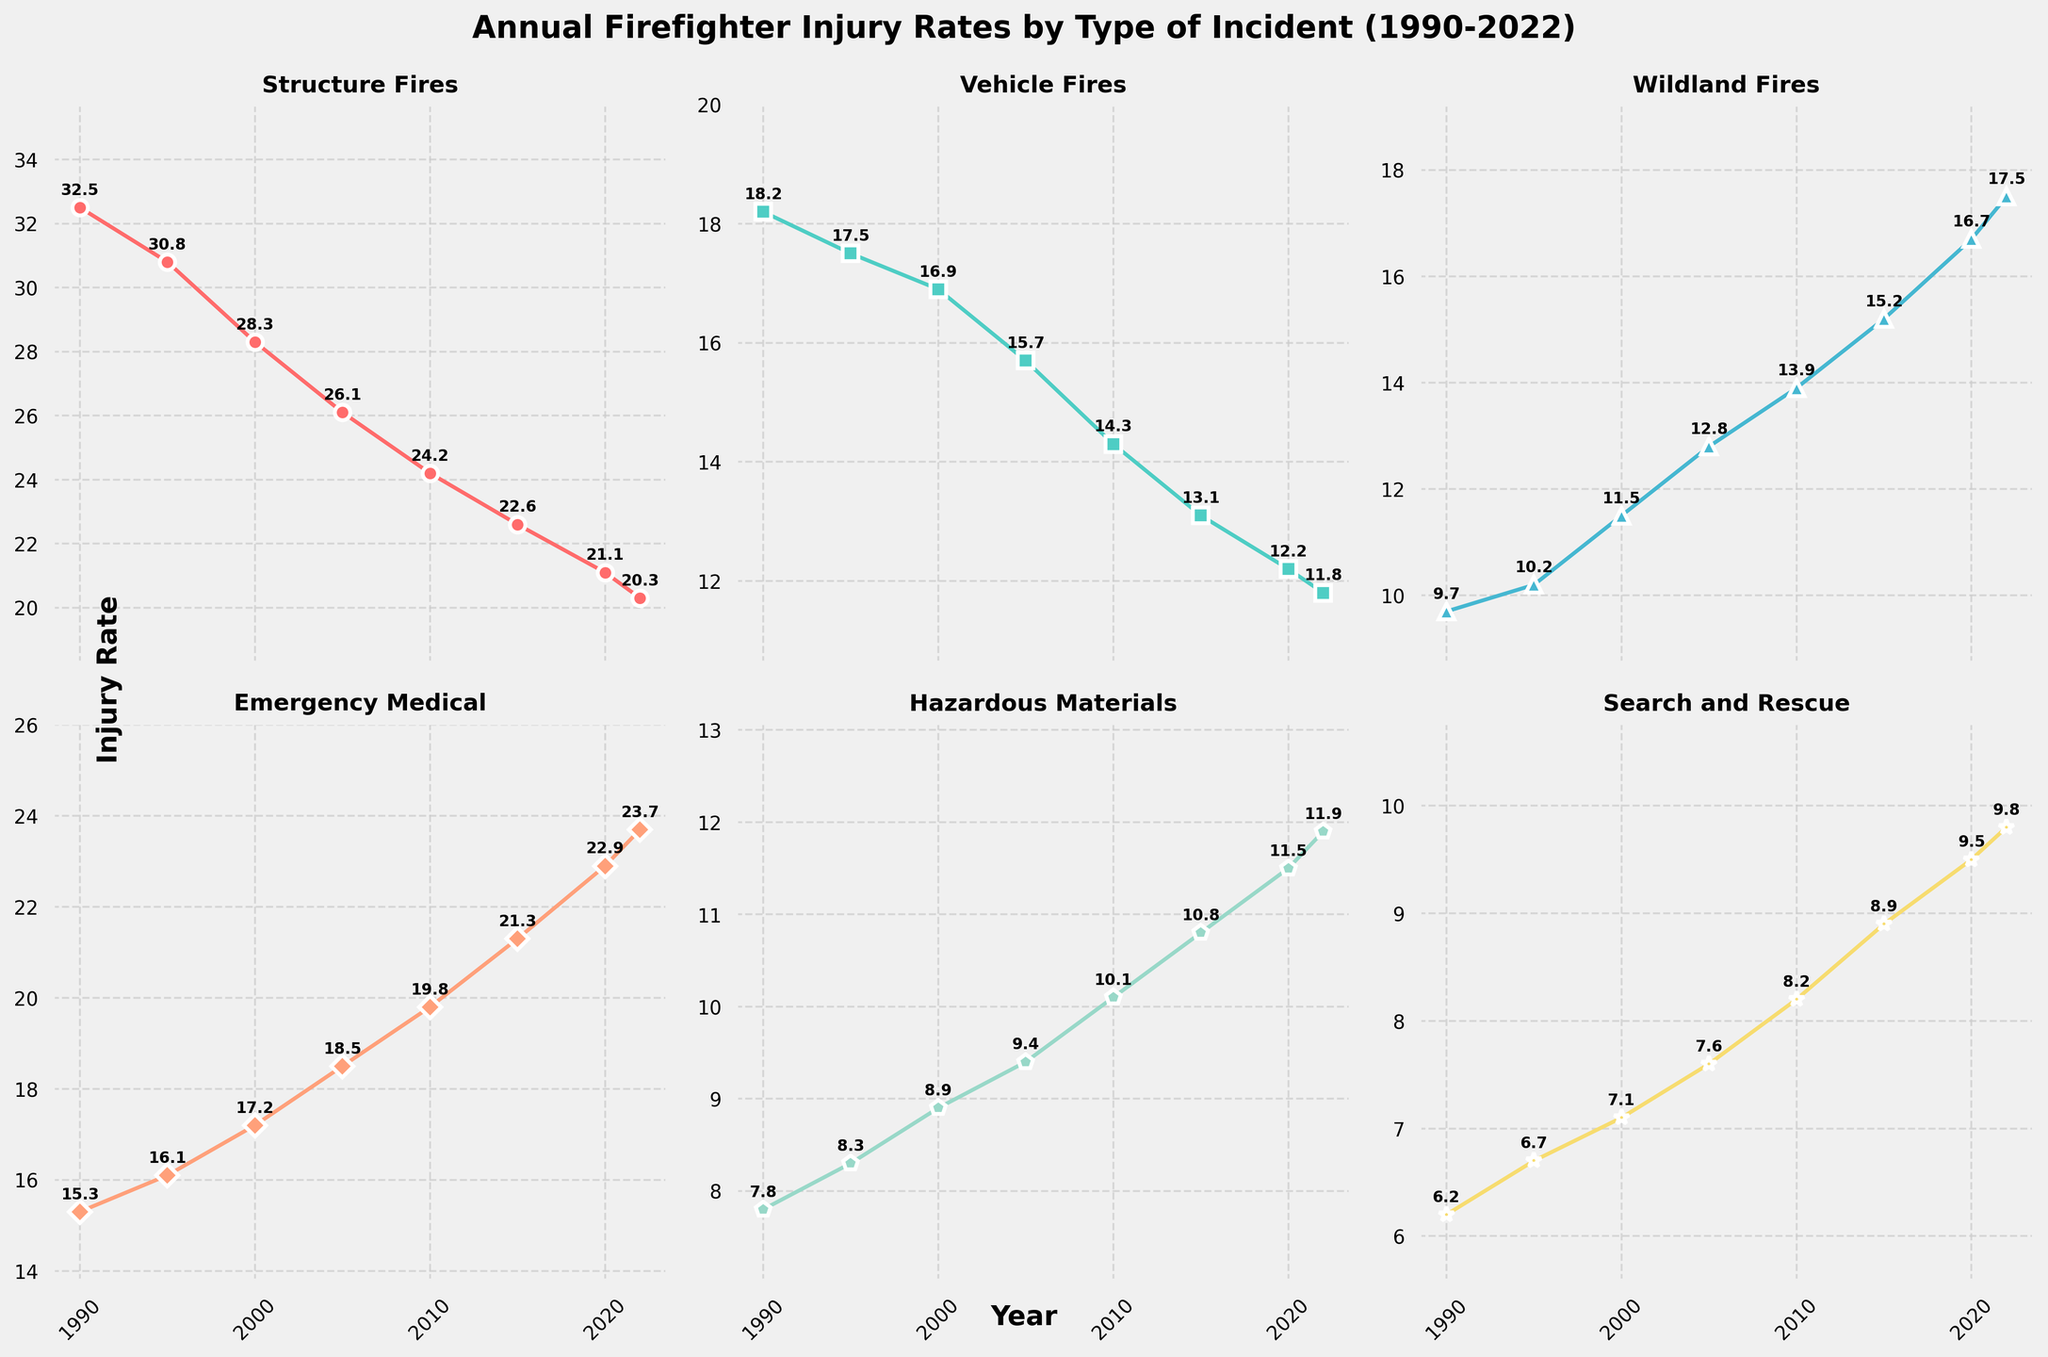What's the title of the figure? The title is displayed at the top of the figure and provides a summary of what the figure represents.
Answer: Annual Firefighter Injury Rates by Type of Incident (1990-2022) How many subplots are in the figure? There are six subplots, arranged in a 2x3 grid, each representing a different type of incident.
Answer: 6 Which type of incident has the highest injury rate in 1990? By looking at the first data point (1990) on each subplot, the "Structure Fires" subplot has the highest value at 32.5.
Answer: Structure Fires Between which years does the "Vehicle Fires" injury rate decrease the most? To find the steepest decrease, examine the differences between consecutive years for the "Vehicle Fires" line. The largest decrease occurs between 1990 (18.2) and 1995 (17.5), a decrease of 0.7.
Answer: 1990-1995 What is the trend of the injury rate for "Wildland Fires" from 1990 to 2022? Observe the "Wildland Fires" subplot. The trend shows a consistent increase in the injury rate from 9.7 in 1990 to 17.5 in 2022.
Answer: Increasing Which incident type shows an overall decreasing trend in the injury rate from 1990 to 2022? Comparing the starting point (1990) and endpoint (2022) for each line, "Structure Fires" shows a decrease from 32.5 to 20.3, indicating an overall decreasing trend.
Answer: Structure Fires What is the average injury rate for "Emergency Medical" incidents from 1990 to 2022? Sum all the injury rates for "Emergency Medical" (15.3 + 16.1 + 17.2 + 18.5 + 19.8 + 21.3 + 22.9 + 23.7) and divide by the number of data points (8). The total is 154.8, so the average is 154.8/8 = 19.35.
Answer: 19.35 In which year do "Hazardous Materials" incidents have the highest injury rate? The highest injury rate for "Hazardous Materials" is 11.9, observed in 2022.
Answer: 2022 Which two years have the closest injury rates for "Search and Rescue"? By comparing injury rates, 2020 (9.5) and 2022 (9.8) are very close, with a difference of only 0.3.
Answer: 2020 and 2022 